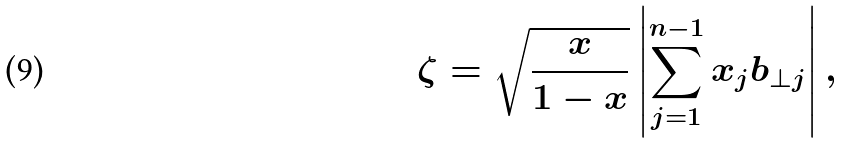<formula> <loc_0><loc_0><loc_500><loc_500>\zeta = \sqrt { \frac { x } { 1 - x } } \left | \sum _ { j = 1 } ^ { n - 1 } x _ { j } b _ { \perp j } \right | ,</formula> 